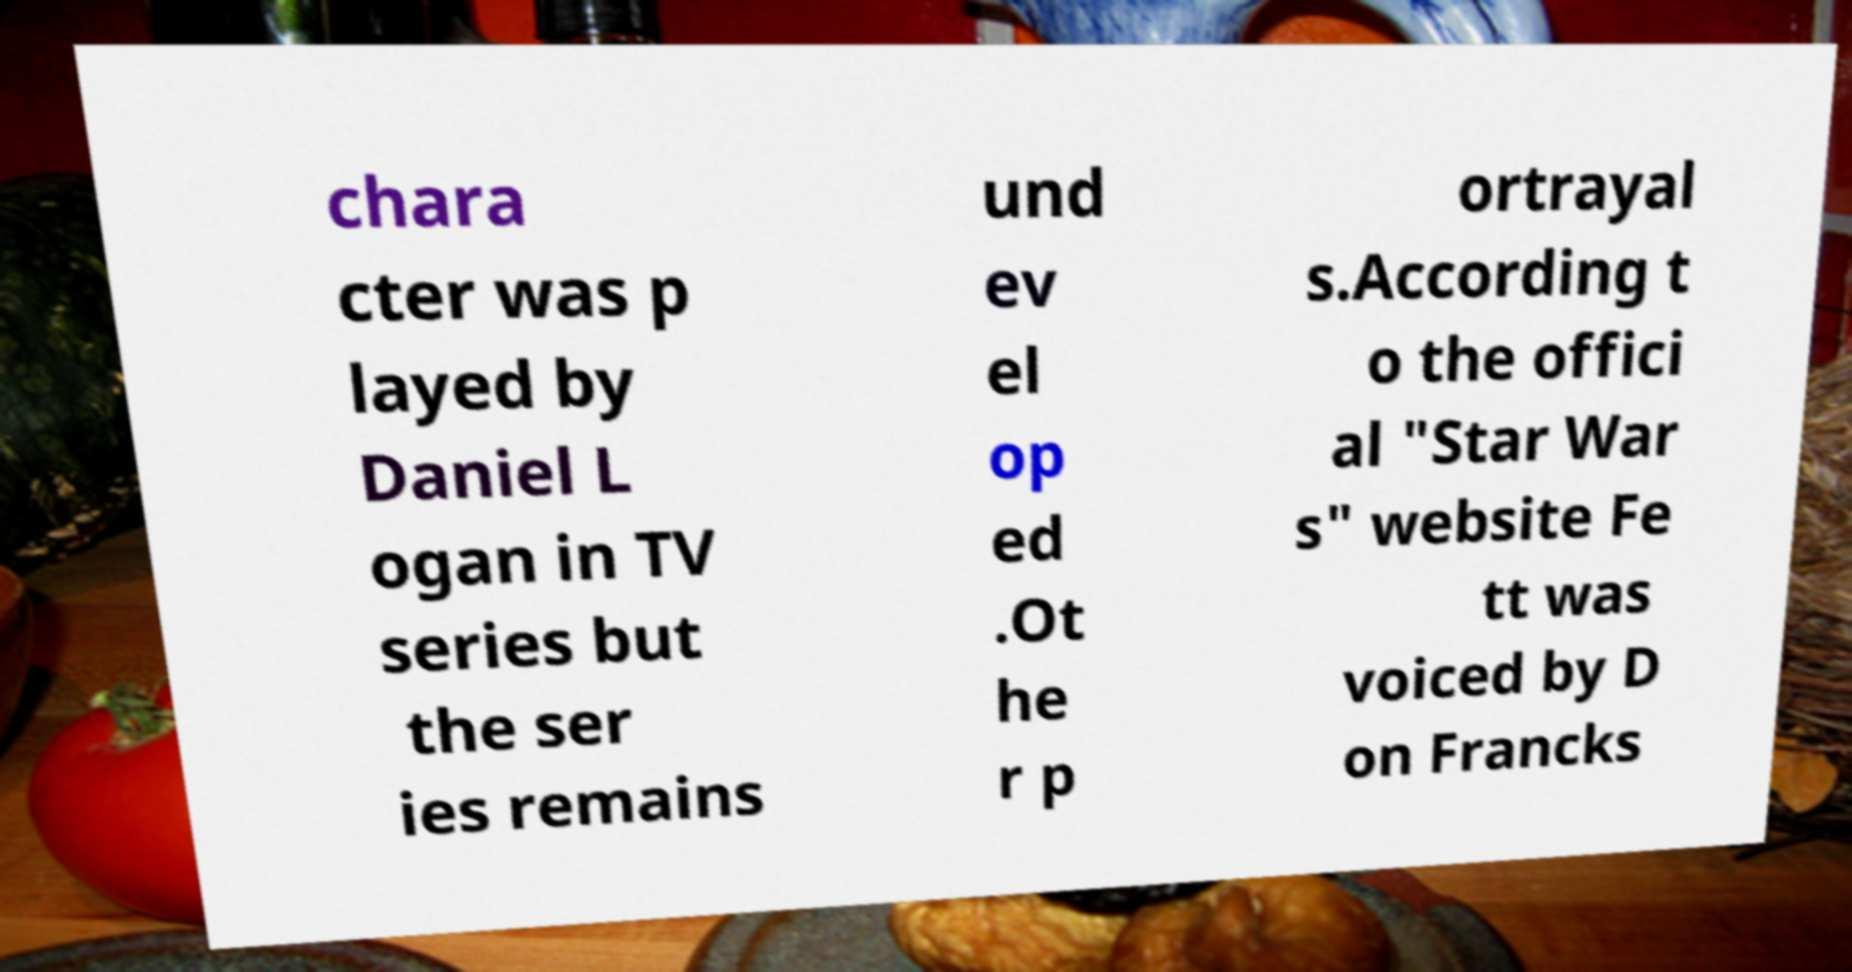Could you extract and type out the text from this image? chara cter was p layed by Daniel L ogan in TV series but the ser ies remains und ev el op ed .Ot he r p ortrayal s.According t o the offici al "Star War s" website Fe tt was voiced by D on Francks 